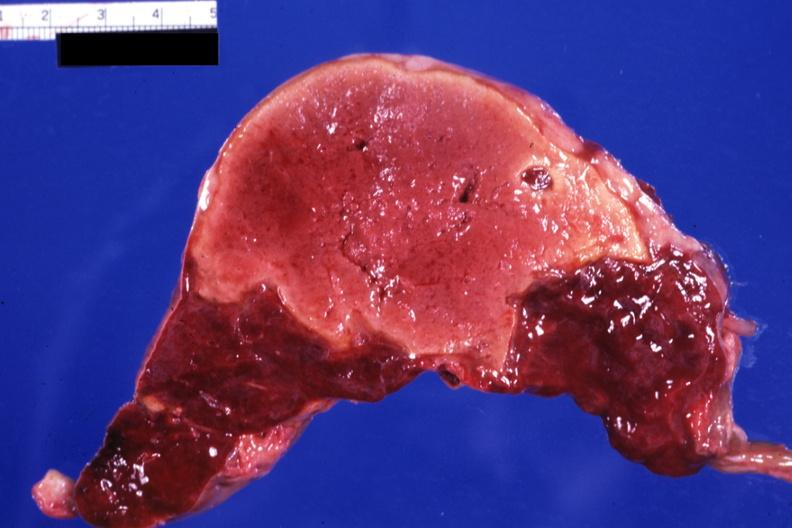what does this image show?
Answer the question using a single word or phrase. Large yellow lesion probably several weeks of age 